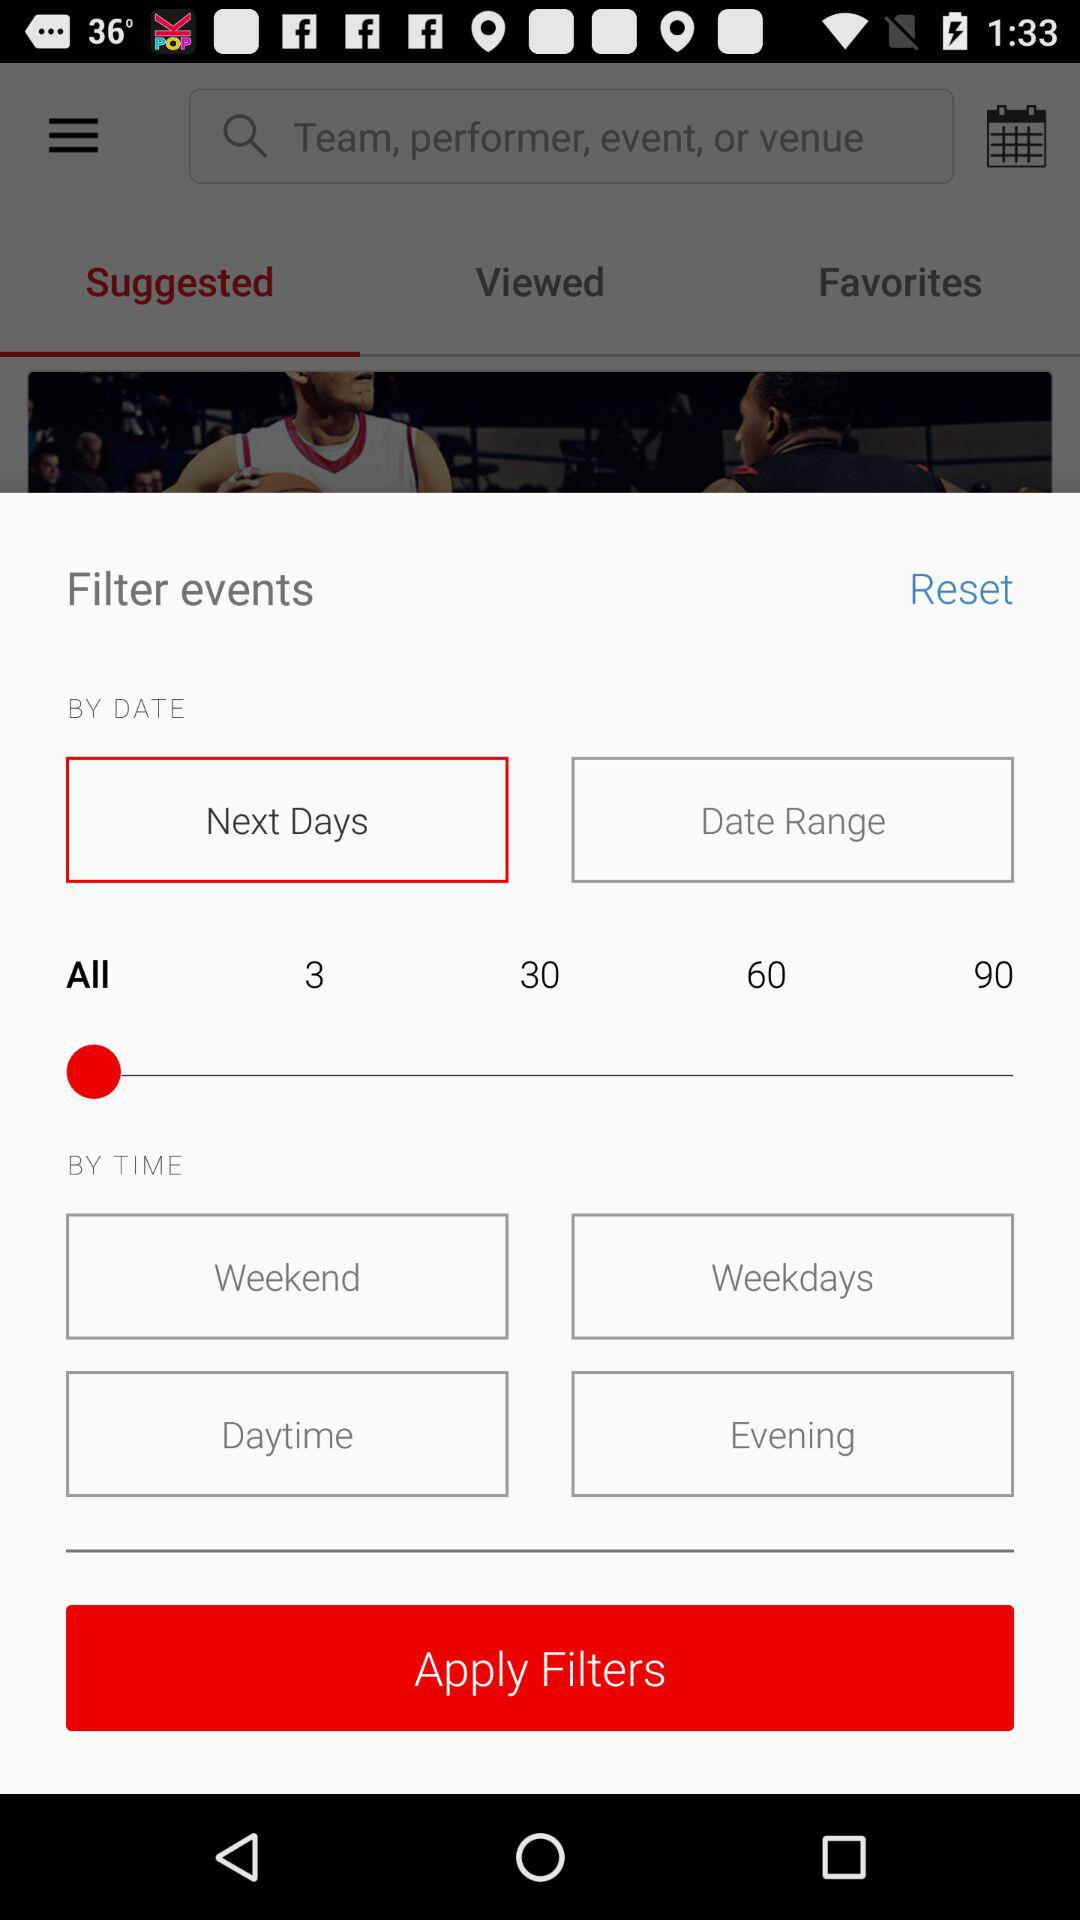What's the selected option in the filter events "BY DATE"? The selected options are "Next Days" and "All". 